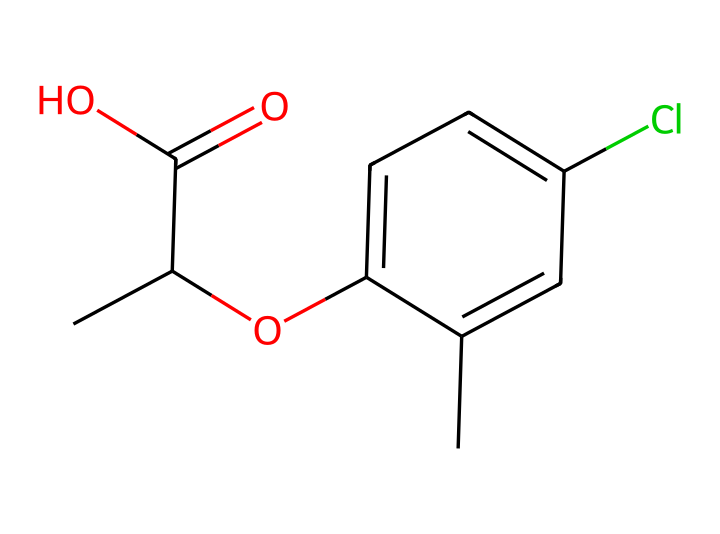What is the main functional group present in mecoprop? The SMILES representation shows a carboxylic acid group (C(=O)O) as part of the structure, indicating that this is the main functional group in mecoprop.
Answer: carboxylic acid How many carbon atoms are in the mecoprop structure? When counting from the SMILES representation, there are a total of 10 carbon atoms present in the entire molecule of mecoprop.
Answer: 10 What type of herbicide is mecoprop classified as? Based on its structure and functional groups, mecoprop is classified as a phenoxy herbicide, typically used for controlling broadleaf weeds.
Answer: phenoxy How many chlorine atoms are there in mecoprop? In the chemical structure derived from the SMILES, there is one chlorine atom indicated by the 'Cl' in the compound, representing the halogenated aspect of mecoprop.
Answer: 1 What is the molecular formula of mecoprop? By analyzing the structure from the SMILES notation, the complete molecular formula deduced is C10H11ClO3, combining information from all elements present.
Answer: C10H11ClO3 What functional groups are present in addition to the carboxylic acid? The structure reveals an ether (-O-) group and a phenolic (-OH) hydroxyl group, indicating the presence of multiple functional groups alongside the carboxylic acid.
Answer: ether, hydroxyl What is the significance of mecoprop’s structure in herbicide activity? The structure with a carboxylic acid and aromatic ring allows mecoprop to mimic natural plant growth hormones, which disrupts the normal growth of unwanted plants, classifying it as an auxin-type herbicide.
Answer: disrupts plant growth 